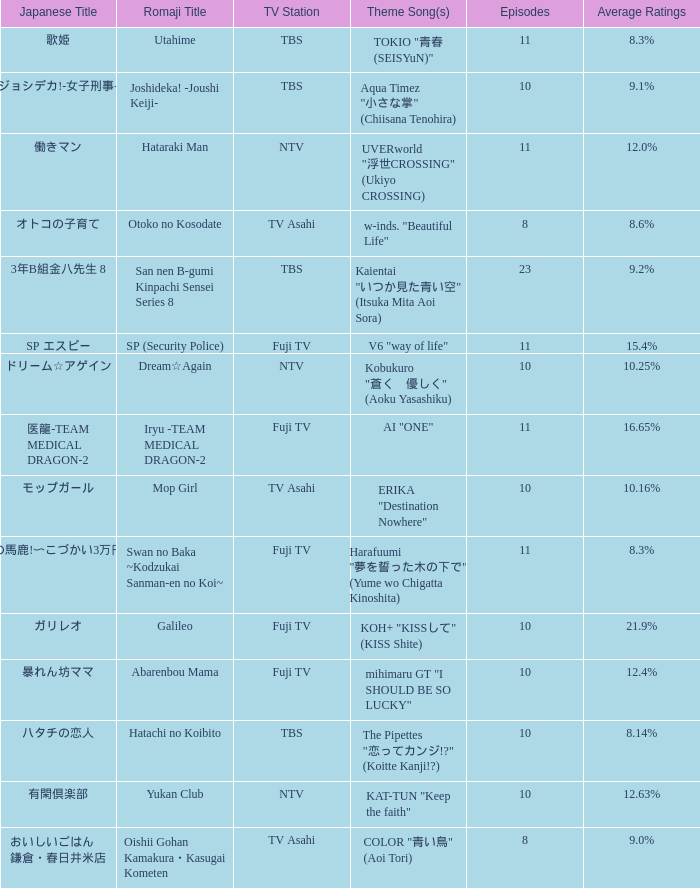What is the Theme Song of the Yukan Club? KAT-TUN "Keep the faith". 